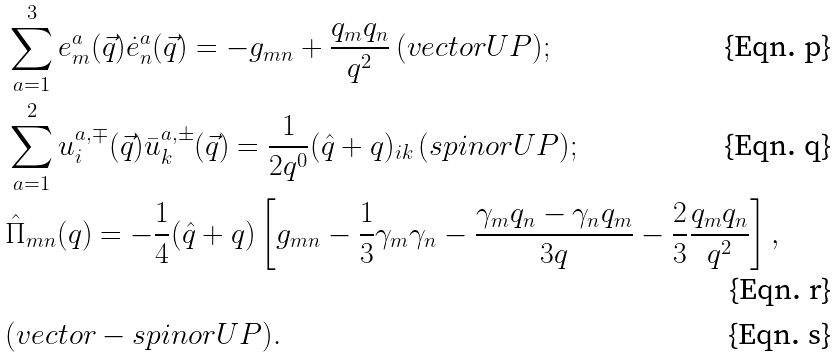Convert formula to latex. <formula><loc_0><loc_0><loc_500><loc_500>& \sum _ { a = 1 } ^ { 3 } e ^ { a } _ { m } ( \vec { q } ) \dot { e } ^ { a } _ { n } ( \vec { q } ) = - g _ { m n } + \frac { q _ { m } q _ { n } } { q ^ { 2 } } \, ( v e c t o r U P ) ; \\ & \sum _ { a = 1 } ^ { 2 } u ^ { a , \mp } _ { i } ( \vec { q } ) \bar { u } ^ { a , \pm } _ { k } ( \vec { q } ) = \frac { 1 } { 2 q ^ { 0 } } ( \hat { q } + q ) _ { i k } \, ( s p i n o r U P ) ; \\ & \hat { \Pi } _ { m n } ( q ) = - \frac { 1 } { 4 } ( \hat { q } + q ) \left [ g _ { m n } - \frac { 1 } { 3 } \gamma _ { m } \gamma _ { n } - \frac { \gamma _ { m } q _ { n } - \gamma _ { n } q _ { m } } { 3 q } - \frac { 2 } { 3 } \frac { q _ { m } q _ { n } } { q ^ { 2 } } \right ] , \\ & ( v e c t o r - s p i n o r U P ) .</formula> 